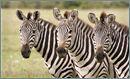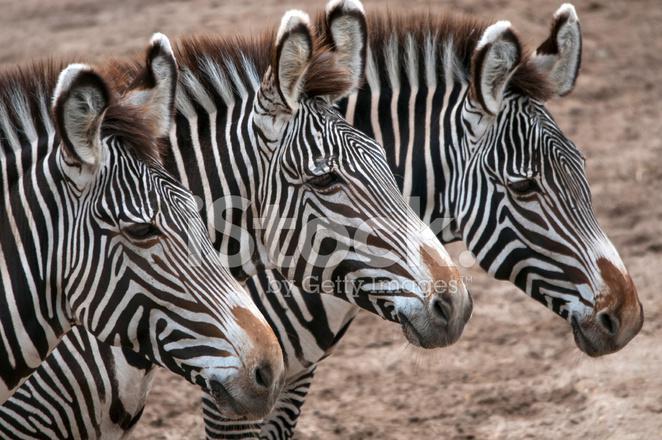The first image is the image on the left, the second image is the image on the right. Examine the images to the left and right. Is the description "Each image features a group of zebras lined up in a symmetrical fashion" accurate? Answer yes or no. Yes. The first image is the image on the left, the second image is the image on the right. Analyze the images presented: Is the assertion "Each image contains three zebras in a neat row, and the zebras in the left and right images are in similar body poses but facing different directions." valid? Answer yes or no. Yes. 